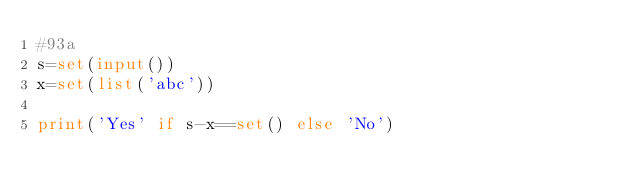Convert code to text. <code><loc_0><loc_0><loc_500><loc_500><_Python_>#93a
s=set(input())
x=set(list('abc'))

print('Yes' if s-x==set() else 'No')
</code> 